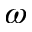<formula> <loc_0><loc_0><loc_500><loc_500>\omega</formula> 